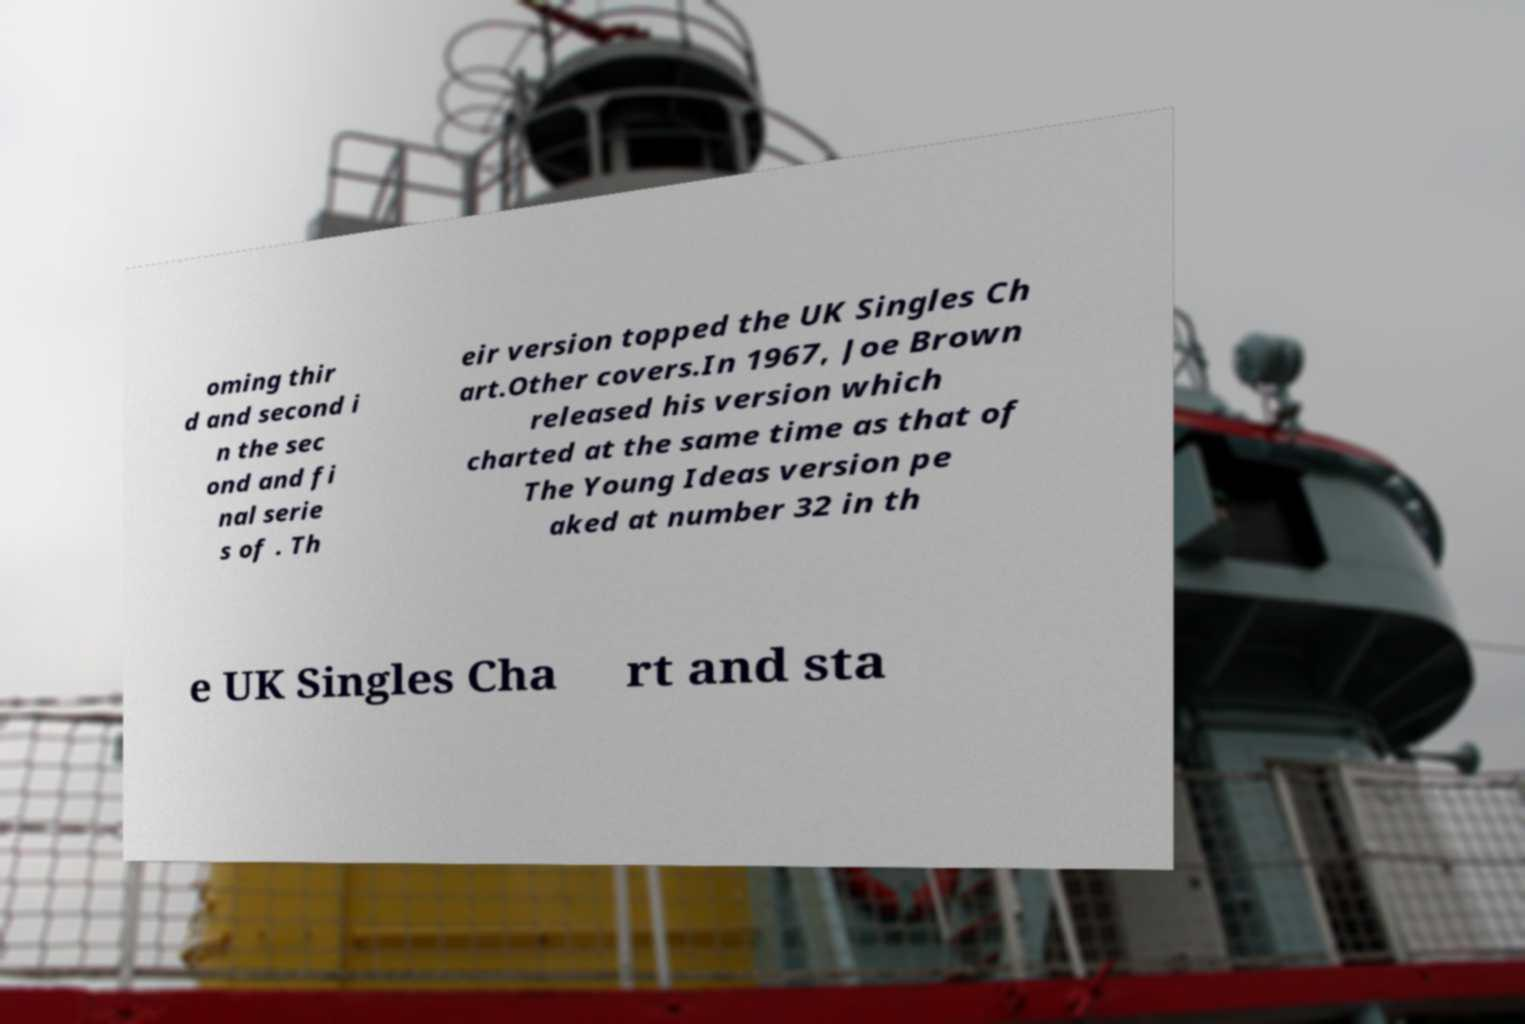What messages or text are displayed in this image? I need them in a readable, typed format. oming thir d and second i n the sec ond and fi nal serie s of . Th eir version topped the UK Singles Ch art.Other covers.In 1967, Joe Brown released his version which charted at the same time as that of The Young Ideas version pe aked at number 32 in th e UK Singles Cha rt and sta 